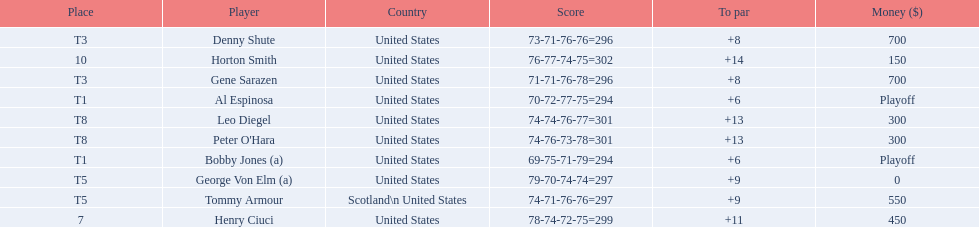Who finished next after bobby jones and al espinosa? Gene Sarazen, Denny Shute. 